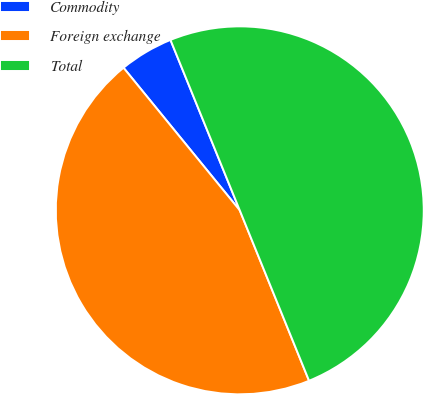Convert chart to OTSL. <chart><loc_0><loc_0><loc_500><loc_500><pie_chart><fcel>Commodity<fcel>Foreign exchange<fcel>Total<nl><fcel>4.74%<fcel>45.26%<fcel>50.0%<nl></chart> 